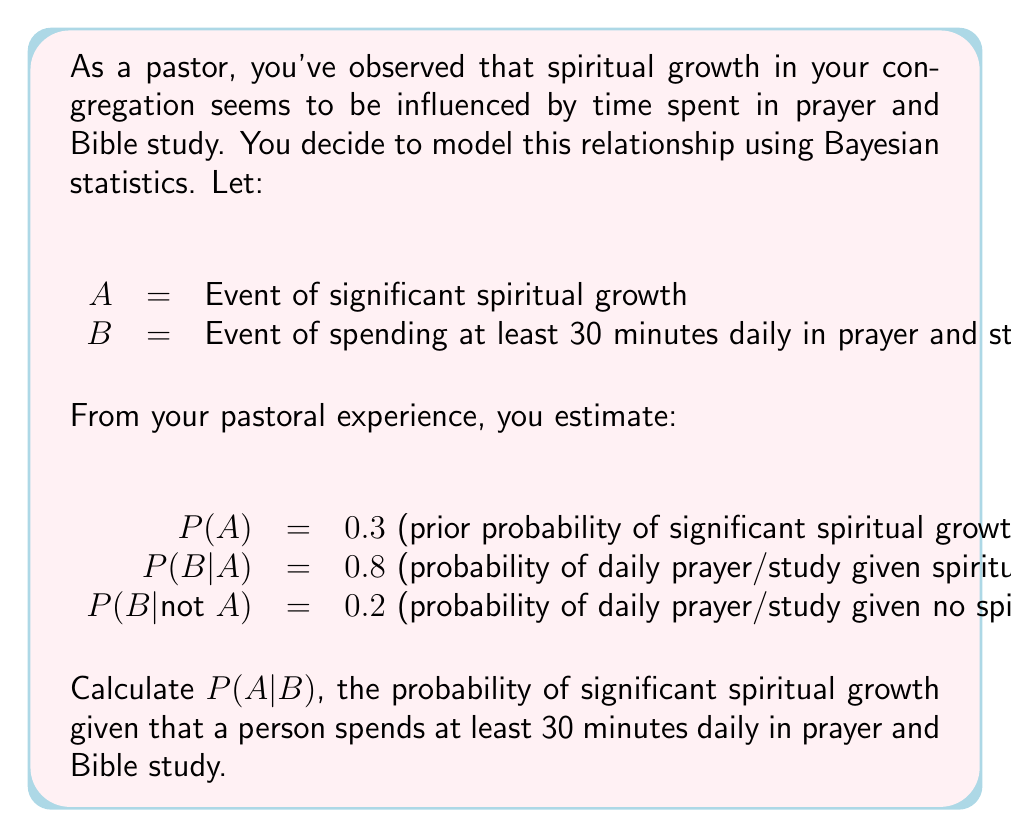Solve this math problem. To solve this problem, we'll use Bayes' Theorem:

$$P(A|B) = \frac{P(B|A) \cdot P(A)}{P(B)}$$

We're given:
$P(A) = 0.3$
$P(B|A) = 0.8$
$P(B|\text{not }A) = 0.2$

First, we need to calculate $P(B)$ using the law of total probability:

$$P(B) = P(B|A) \cdot P(A) + P(B|\text{not }A) \cdot P(\text{not }A)$$

$P(\text{not }A) = 1 - P(A) = 1 - 0.3 = 0.7$

Now, let's calculate $P(B)$:

$$P(B) = 0.8 \cdot 0.3 + 0.2 \cdot 0.7 = 0.24 + 0.14 = 0.38$$

Now we have all the components to apply Bayes' Theorem:

$$P(A|B) = \frac{0.8 \cdot 0.3}{0.38} = \frac{0.24}{0.38} \approx 0.6316$$

Therefore, the probability of significant spiritual growth given that a person spends at least 30 minutes daily in prayer and Bible study is approximately 0.6316 or 63.16%.
Answer: $P(A|B) \approx 0.6316$ or $63.16\%$ 